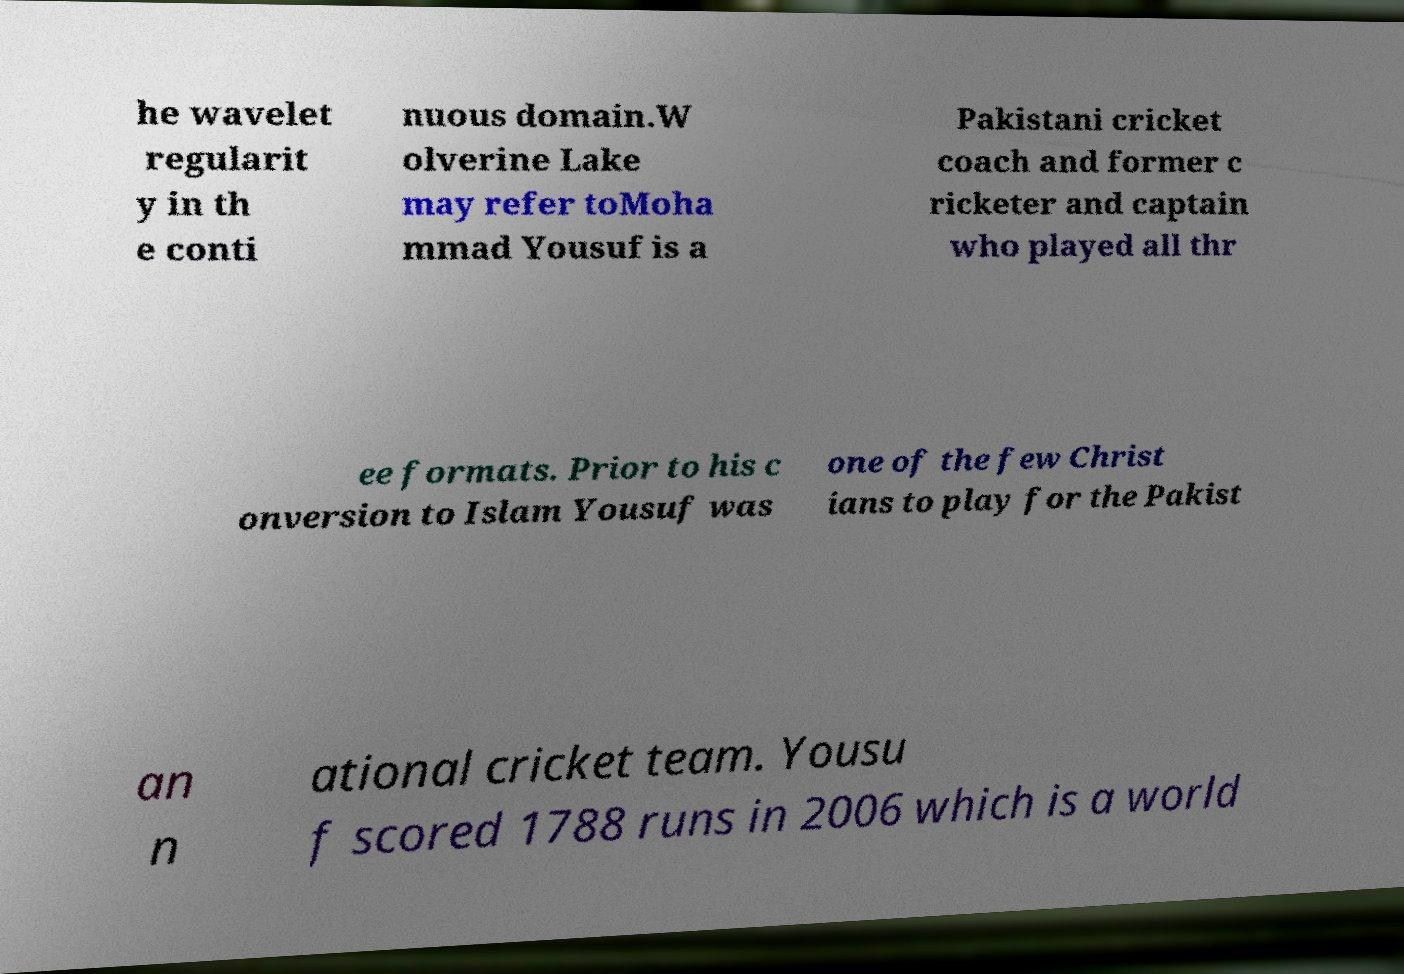Please identify and transcribe the text found in this image. he wavelet regularit y in th e conti nuous domain.W olverine Lake may refer toMoha mmad Yousuf is a Pakistani cricket coach and former c ricketer and captain who played all thr ee formats. Prior to his c onversion to Islam Yousuf was one of the few Christ ians to play for the Pakist an n ational cricket team. Yousu f scored 1788 runs in 2006 which is a world 